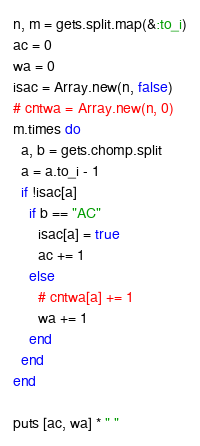<code> <loc_0><loc_0><loc_500><loc_500><_Ruby_>n, m = gets.split.map(&:to_i)
ac = 0
wa = 0
isac = Array.new(n, false)
# cntwa = Array.new(n, 0)
m.times do
  a, b = gets.chomp.split
  a = a.to_i - 1
  if !isac[a]
    if b == "AC"
      isac[a] = true
      ac += 1
    else
      # cntwa[a] += 1
      wa += 1
    end
  end
end

puts [ac, wa] * " "
</code> 